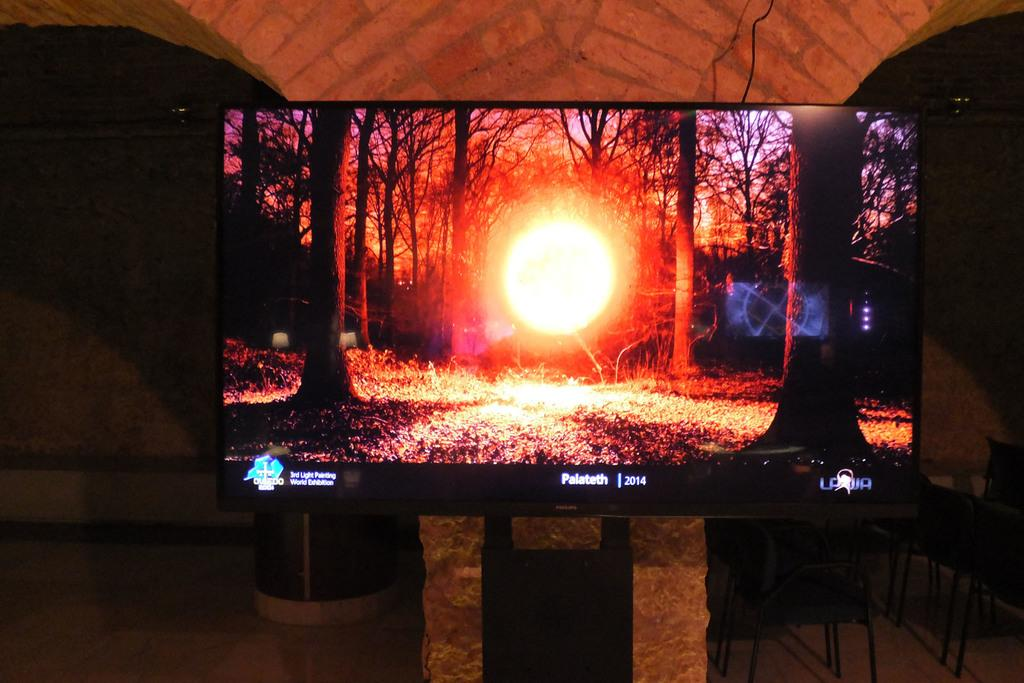<image>
Summarize the visual content of the image. The television screen shows a light in a forest and the year 2014. 